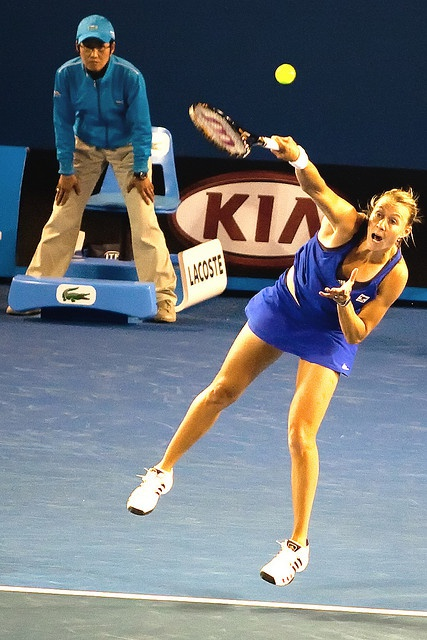Describe the objects in this image and their specific colors. I can see people in black, navy, ivory, brown, and orange tones, people in black, blue, navy, and tan tones, tennis racket in black and tan tones, and sports ball in black, yellow, and khaki tones in this image. 